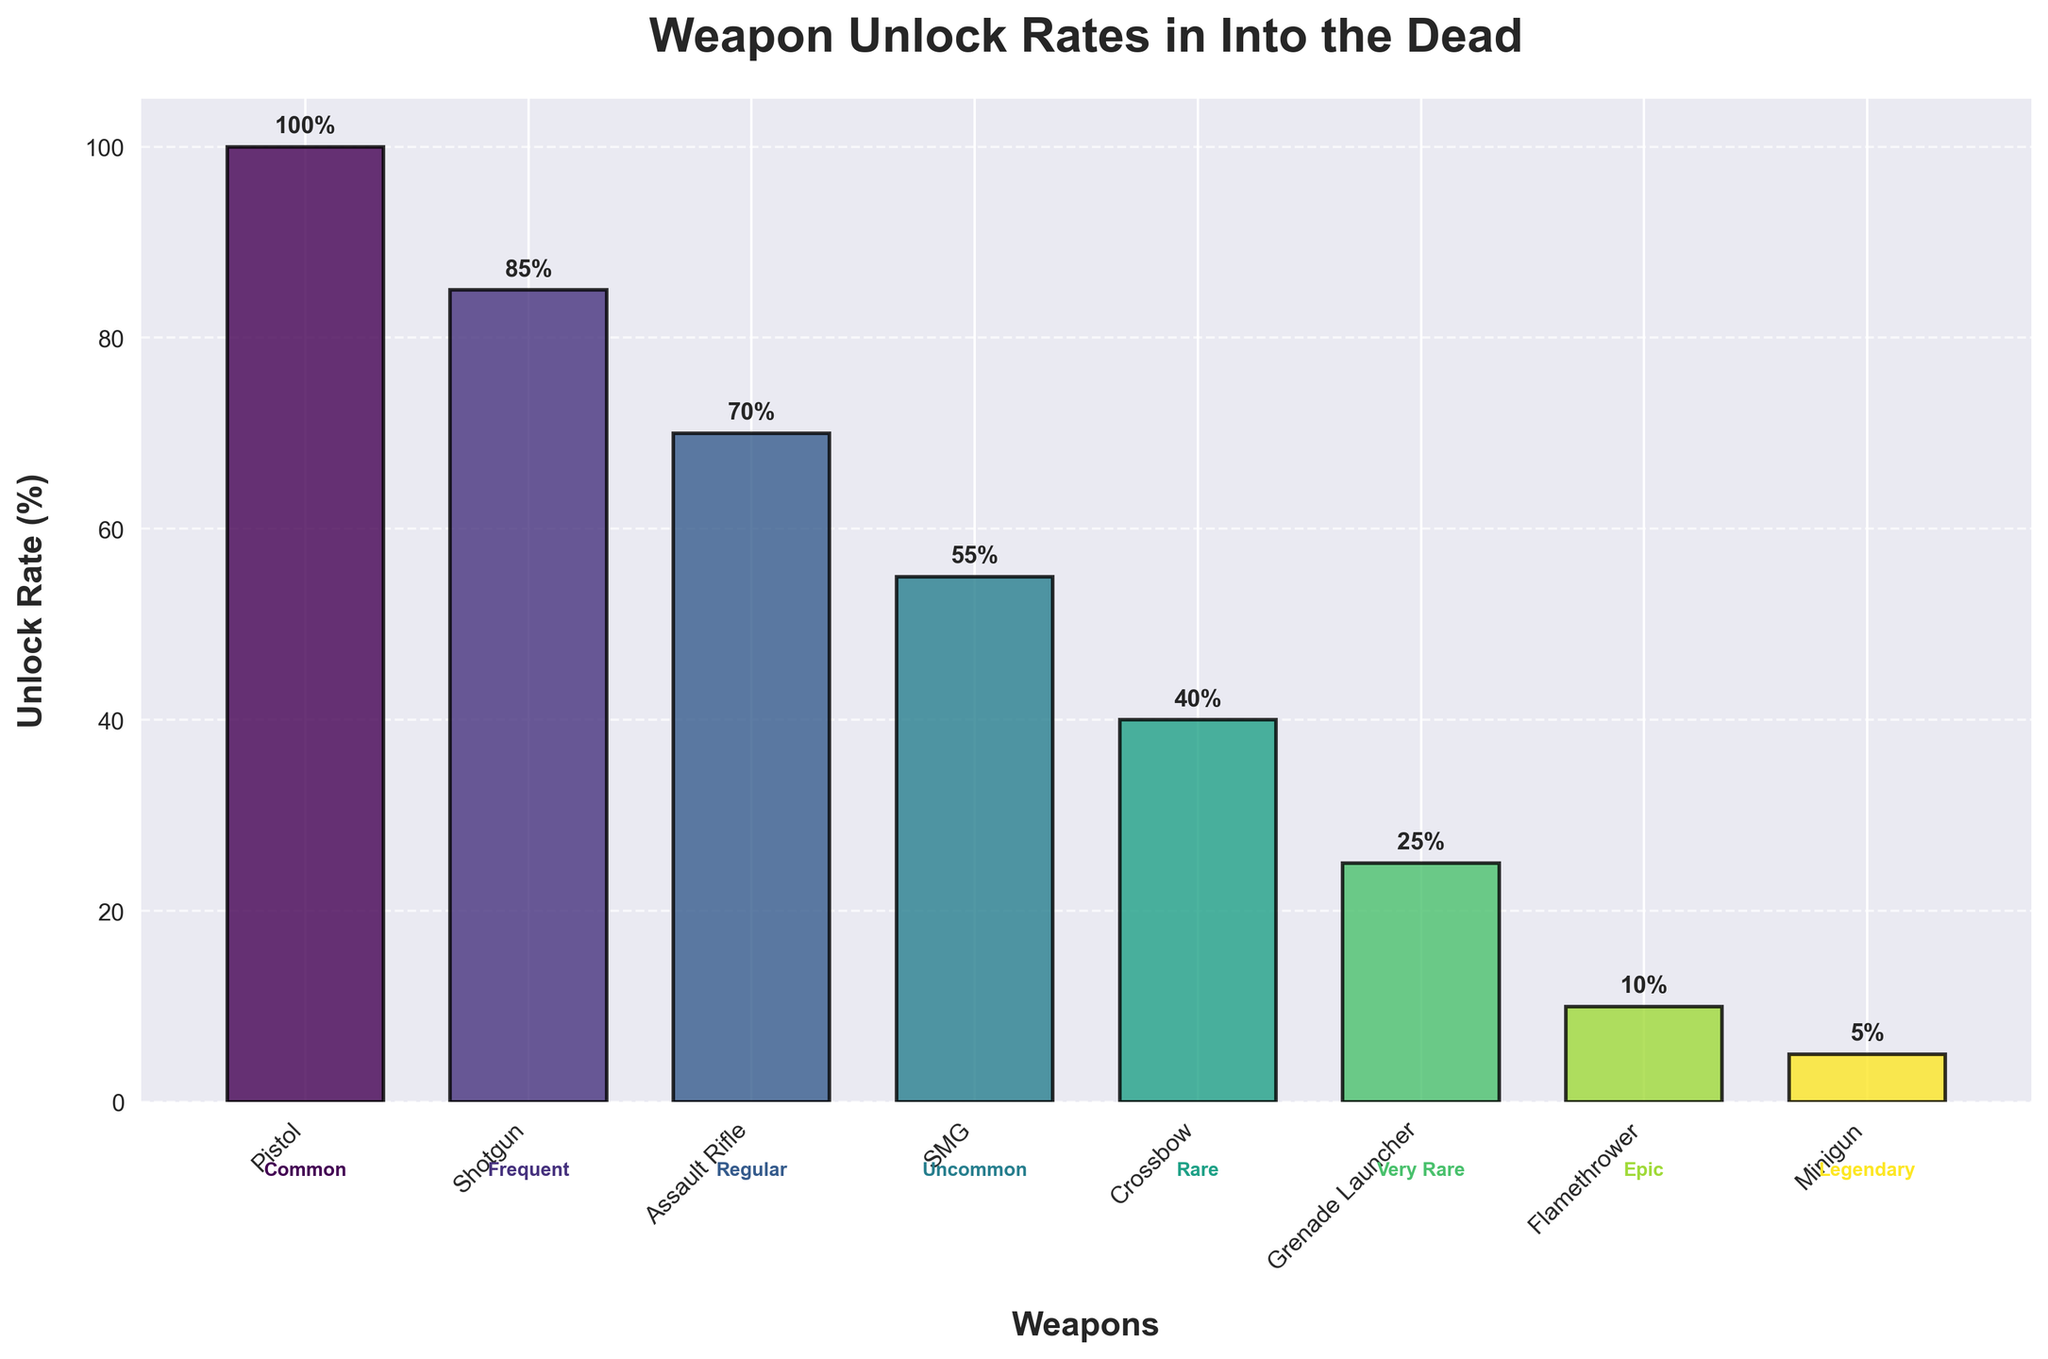What's the most common weapon unlock rate? The most common weapon unlock rate is shown at the top of the funnel chart. The Pistol has the highest unlock rate of 100%.
Answer: 100% Which weapon has the rarest unlock rate? The rarest unlock rate is shown at the bottom of the funnel chart. The Minigun has the lowest unlock rate of 5%.
Answer: Minigun How many weapons have an unlock rate above 50%? To find this, count the number of weapons that have unlock rates greater than 50% which are Pistol, Shotgun, and Assault Rifle (3 weapons). The counts are from left to right of the funnel chart.
Answer: 3 What's the difference in unlock rates between the Assault Rifle and the Flamethrower? The unlock rates are 70% for the Assault Rifle and 10% for the Flamethrower. The difference is calculated as 70% - 10% = 60%.
Answer: 60% What is the average unlock rate of all the weapons? Sum all the unlock rates (100 + 85 + 70 + 55 + 40 + 25 + 10 + 5 = 390) and divide by the number of weapons (8). The average unlock rate is 390 / 8 = 48.75%.
Answer: 48.75% Which weapon has an unlock rate closest to 50%? Looking at the figure, the closest unlock rate to 50% is 55% for the SMG.
Answer: SMG How does the unlock rate for the Grenade Launcher compare to the Shotgun? The unlock rate for the Grenade Launcher is 25%, and for the Shotgun, it is 85%. The Shotgun has a higher unlock rate by 60% (85% - 25%).
Answer: 60% What stage corresponds to the Crossbow? The Crossbow's stage is identified by the color annotation placed below its location in the chart, which shows the term "Rare".
Answer: Rare How many stages are denoted in the chart? By examining the funnel chart annotations, we observe 8 distinct stages listed.
Answer: 8 Which weapon has the second lowest unlock rate? The weapon with the second lowest unlock rate after the Minigun (5%) is the Flamethrower with a 10% unlock rate.
Answer: Flamethrower 